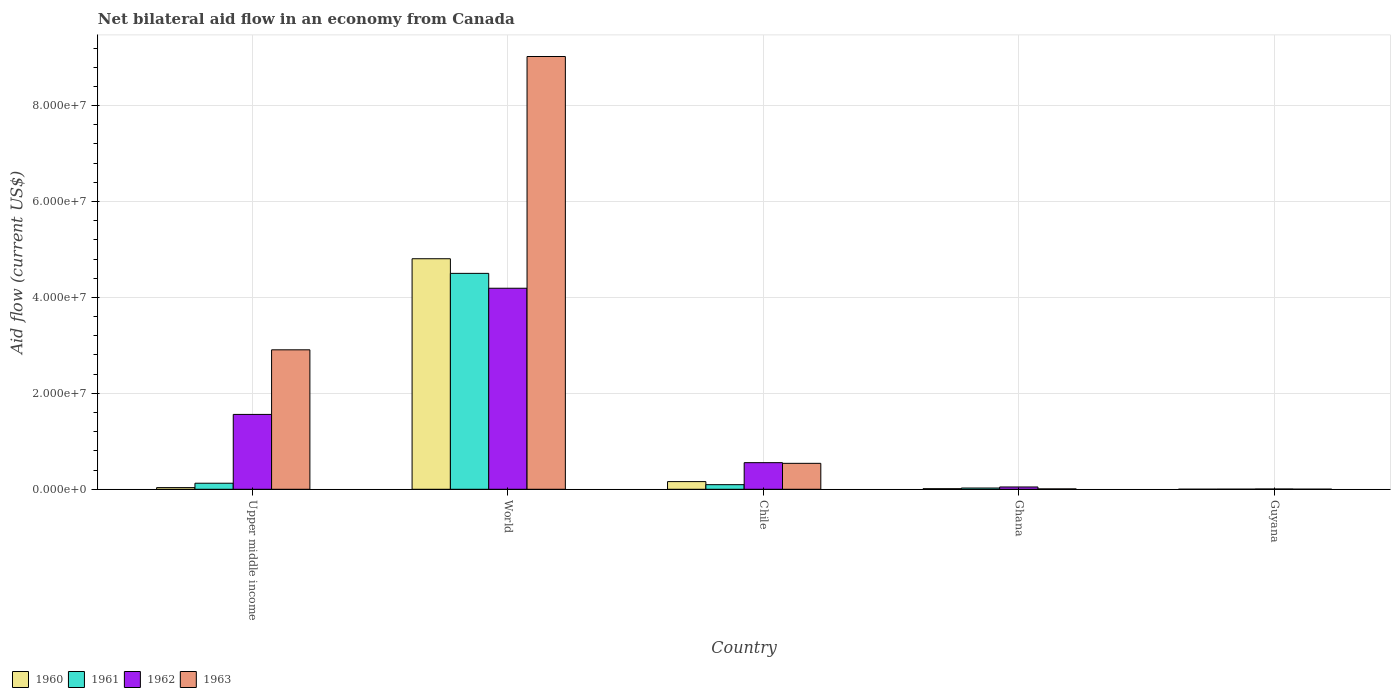How many different coloured bars are there?
Your response must be concise. 4. Are the number of bars per tick equal to the number of legend labels?
Your response must be concise. Yes. Are the number of bars on each tick of the X-axis equal?
Keep it short and to the point. Yes. How many bars are there on the 2nd tick from the left?
Provide a short and direct response. 4. What is the label of the 3rd group of bars from the left?
Provide a succinct answer. Chile. In how many cases, is the number of bars for a given country not equal to the number of legend labels?
Your answer should be very brief. 0. What is the net bilateral aid flow in 1961 in Ghana?
Provide a succinct answer. 2.60e+05. Across all countries, what is the maximum net bilateral aid flow in 1963?
Ensure brevity in your answer.  9.02e+07. In which country was the net bilateral aid flow in 1962 maximum?
Offer a terse response. World. In which country was the net bilateral aid flow in 1962 minimum?
Your answer should be very brief. Guyana. What is the total net bilateral aid flow in 1961 in the graph?
Your answer should be very brief. 4.75e+07. What is the difference between the net bilateral aid flow in 1962 in Ghana and that in Upper middle income?
Your answer should be compact. -1.51e+07. What is the difference between the net bilateral aid flow in 1961 in World and the net bilateral aid flow in 1962 in Chile?
Offer a very short reply. 3.95e+07. What is the average net bilateral aid flow in 1961 per country?
Keep it short and to the point. 9.50e+06. In how many countries, is the net bilateral aid flow in 1961 greater than 80000000 US$?
Make the answer very short. 0. What is the ratio of the net bilateral aid flow in 1960 in Ghana to that in Upper middle income?
Make the answer very short. 0.34. Is the difference between the net bilateral aid flow in 1962 in Guyana and World greater than the difference between the net bilateral aid flow in 1961 in Guyana and World?
Offer a terse response. Yes. What is the difference between the highest and the second highest net bilateral aid flow in 1962?
Give a very brief answer. 2.63e+07. What is the difference between the highest and the lowest net bilateral aid flow in 1962?
Provide a succinct answer. 4.19e+07. Is the sum of the net bilateral aid flow in 1963 in Chile and Upper middle income greater than the maximum net bilateral aid flow in 1962 across all countries?
Your answer should be compact. No. Are all the bars in the graph horizontal?
Provide a succinct answer. No. Does the graph contain any zero values?
Give a very brief answer. No. Does the graph contain grids?
Ensure brevity in your answer.  Yes. Where does the legend appear in the graph?
Give a very brief answer. Bottom left. How many legend labels are there?
Offer a very short reply. 4. How are the legend labels stacked?
Make the answer very short. Horizontal. What is the title of the graph?
Make the answer very short. Net bilateral aid flow in an economy from Canada. What is the label or title of the Y-axis?
Give a very brief answer. Aid flow (current US$). What is the Aid flow (current US$) in 1961 in Upper middle income?
Offer a very short reply. 1.26e+06. What is the Aid flow (current US$) in 1962 in Upper middle income?
Your answer should be very brief. 1.56e+07. What is the Aid flow (current US$) of 1963 in Upper middle income?
Ensure brevity in your answer.  2.91e+07. What is the Aid flow (current US$) in 1960 in World?
Make the answer very short. 4.81e+07. What is the Aid flow (current US$) of 1961 in World?
Ensure brevity in your answer.  4.50e+07. What is the Aid flow (current US$) in 1962 in World?
Ensure brevity in your answer.  4.19e+07. What is the Aid flow (current US$) in 1963 in World?
Your answer should be compact. 9.02e+07. What is the Aid flow (current US$) in 1960 in Chile?
Keep it short and to the point. 1.60e+06. What is the Aid flow (current US$) in 1961 in Chile?
Offer a very short reply. 9.60e+05. What is the Aid flow (current US$) of 1962 in Chile?
Provide a succinct answer. 5.55e+06. What is the Aid flow (current US$) in 1963 in Chile?
Your answer should be compact. 5.41e+06. What is the Aid flow (current US$) in 1960 in Ghana?
Your response must be concise. 1.20e+05. What is the Aid flow (current US$) of 1961 in Ghana?
Offer a terse response. 2.60e+05. What is the Aid flow (current US$) of 1962 in Ghana?
Keep it short and to the point. 4.80e+05. Across all countries, what is the maximum Aid flow (current US$) of 1960?
Your response must be concise. 4.81e+07. Across all countries, what is the maximum Aid flow (current US$) of 1961?
Make the answer very short. 4.50e+07. Across all countries, what is the maximum Aid flow (current US$) in 1962?
Give a very brief answer. 4.19e+07. Across all countries, what is the maximum Aid flow (current US$) of 1963?
Provide a short and direct response. 9.02e+07. Across all countries, what is the minimum Aid flow (current US$) of 1960?
Offer a terse response. 10000. Across all countries, what is the minimum Aid flow (current US$) in 1961?
Your response must be concise. 2.00e+04. Across all countries, what is the minimum Aid flow (current US$) in 1963?
Keep it short and to the point. 2.00e+04. What is the total Aid flow (current US$) of 1960 in the graph?
Keep it short and to the point. 5.02e+07. What is the total Aid flow (current US$) of 1961 in the graph?
Your answer should be compact. 4.75e+07. What is the total Aid flow (current US$) of 1962 in the graph?
Keep it short and to the point. 6.36e+07. What is the total Aid flow (current US$) in 1963 in the graph?
Give a very brief answer. 1.25e+08. What is the difference between the Aid flow (current US$) in 1960 in Upper middle income and that in World?
Give a very brief answer. -4.77e+07. What is the difference between the Aid flow (current US$) in 1961 in Upper middle income and that in World?
Make the answer very short. -4.38e+07. What is the difference between the Aid flow (current US$) in 1962 in Upper middle income and that in World?
Give a very brief answer. -2.63e+07. What is the difference between the Aid flow (current US$) in 1963 in Upper middle income and that in World?
Make the answer very short. -6.12e+07. What is the difference between the Aid flow (current US$) of 1960 in Upper middle income and that in Chile?
Your answer should be compact. -1.25e+06. What is the difference between the Aid flow (current US$) in 1962 in Upper middle income and that in Chile?
Ensure brevity in your answer.  1.01e+07. What is the difference between the Aid flow (current US$) in 1963 in Upper middle income and that in Chile?
Your answer should be very brief. 2.37e+07. What is the difference between the Aid flow (current US$) in 1960 in Upper middle income and that in Ghana?
Offer a terse response. 2.30e+05. What is the difference between the Aid flow (current US$) in 1962 in Upper middle income and that in Ghana?
Your response must be concise. 1.51e+07. What is the difference between the Aid flow (current US$) in 1963 in Upper middle income and that in Ghana?
Give a very brief answer. 2.90e+07. What is the difference between the Aid flow (current US$) in 1961 in Upper middle income and that in Guyana?
Keep it short and to the point. 1.24e+06. What is the difference between the Aid flow (current US$) of 1962 in Upper middle income and that in Guyana?
Keep it short and to the point. 1.56e+07. What is the difference between the Aid flow (current US$) in 1963 in Upper middle income and that in Guyana?
Offer a terse response. 2.91e+07. What is the difference between the Aid flow (current US$) in 1960 in World and that in Chile?
Your answer should be compact. 4.65e+07. What is the difference between the Aid flow (current US$) of 1961 in World and that in Chile?
Give a very brief answer. 4.41e+07. What is the difference between the Aid flow (current US$) of 1962 in World and that in Chile?
Offer a terse response. 3.64e+07. What is the difference between the Aid flow (current US$) in 1963 in World and that in Chile?
Your response must be concise. 8.48e+07. What is the difference between the Aid flow (current US$) in 1960 in World and that in Ghana?
Your answer should be compact. 4.80e+07. What is the difference between the Aid flow (current US$) in 1961 in World and that in Ghana?
Your answer should be very brief. 4.48e+07. What is the difference between the Aid flow (current US$) of 1962 in World and that in Ghana?
Ensure brevity in your answer.  4.14e+07. What is the difference between the Aid flow (current US$) of 1963 in World and that in Ghana?
Provide a short and direct response. 9.02e+07. What is the difference between the Aid flow (current US$) in 1960 in World and that in Guyana?
Offer a terse response. 4.81e+07. What is the difference between the Aid flow (current US$) of 1961 in World and that in Guyana?
Your answer should be very brief. 4.50e+07. What is the difference between the Aid flow (current US$) of 1962 in World and that in Guyana?
Your response must be concise. 4.19e+07. What is the difference between the Aid flow (current US$) in 1963 in World and that in Guyana?
Your answer should be very brief. 9.02e+07. What is the difference between the Aid flow (current US$) of 1960 in Chile and that in Ghana?
Your response must be concise. 1.48e+06. What is the difference between the Aid flow (current US$) of 1961 in Chile and that in Ghana?
Give a very brief answer. 7.00e+05. What is the difference between the Aid flow (current US$) in 1962 in Chile and that in Ghana?
Your answer should be very brief. 5.07e+06. What is the difference between the Aid flow (current US$) of 1963 in Chile and that in Ghana?
Offer a very short reply. 5.33e+06. What is the difference between the Aid flow (current US$) in 1960 in Chile and that in Guyana?
Your response must be concise. 1.59e+06. What is the difference between the Aid flow (current US$) of 1961 in Chile and that in Guyana?
Keep it short and to the point. 9.40e+05. What is the difference between the Aid flow (current US$) in 1962 in Chile and that in Guyana?
Offer a terse response. 5.49e+06. What is the difference between the Aid flow (current US$) of 1963 in Chile and that in Guyana?
Your answer should be very brief. 5.39e+06. What is the difference between the Aid flow (current US$) of 1960 in Ghana and that in Guyana?
Your response must be concise. 1.10e+05. What is the difference between the Aid flow (current US$) of 1961 in Ghana and that in Guyana?
Provide a short and direct response. 2.40e+05. What is the difference between the Aid flow (current US$) in 1962 in Ghana and that in Guyana?
Give a very brief answer. 4.20e+05. What is the difference between the Aid flow (current US$) of 1963 in Ghana and that in Guyana?
Give a very brief answer. 6.00e+04. What is the difference between the Aid flow (current US$) of 1960 in Upper middle income and the Aid flow (current US$) of 1961 in World?
Keep it short and to the point. -4.47e+07. What is the difference between the Aid flow (current US$) of 1960 in Upper middle income and the Aid flow (current US$) of 1962 in World?
Give a very brief answer. -4.16e+07. What is the difference between the Aid flow (current US$) in 1960 in Upper middle income and the Aid flow (current US$) in 1963 in World?
Ensure brevity in your answer.  -8.99e+07. What is the difference between the Aid flow (current US$) of 1961 in Upper middle income and the Aid flow (current US$) of 1962 in World?
Give a very brief answer. -4.07e+07. What is the difference between the Aid flow (current US$) in 1961 in Upper middle income and the Aid flow (current US$) in 1963 in World?
Offer a terse response. -8.90e+07. What is the difference between the Aid flow (current US$) of 1962 in Upper middle income and the Aid flow (current US$) of 1963 in World?
Give a very brief answer. -7.46e+07. What is the difference between the Aid flow (current US$) of 1960 in Upper middle income and the Aid flow (current US$) of 1961 in Chile?
Your answer should be very brief. -6.10e+05. What is the difference between the Aid flow (current US$) of 1960 in Upper middle income and the Aid flow (current US$) of 1962 in Chile?
Give a very brief answer. -5.20e+06. What is the difference between the Aid flow (current US$) in 1960 in Upper middle income and the Aid flow (current US$) in 1963 in Chile?
Provide a succinct answer. -5.06e+06. What is the difference between the Aid flow (current US$) of 1961 in Upper middle income and the Aid flow (current US$) of 1962 in Chile?
Your answer should be compact. -4.29e+06. What is the difference between the Aid flow (current US$) in 1961 in Upper middle income and the Aid flow (current US$) in 1963 in Chile?
Offer a terse response. -4.15e+06. What is the difference between the Aid flow (current US$) in 1962 in Upper middle income and the Aid flow (current US$) in 1963 in Chile?
Keep it short and to the point. 1.02e+07. What is the difference between the Aid flow (current US$) of 1960 in Upper middle income and the Aid flow (current US$) of 1961 in Ghana?
Offer a very short reply. 9.00e+04. What is the difference between the Aid flow (current US$) in 1960 in Upper middle income and the Aid flow (current US$) in 1962 in Ghana?
Provide a short and direct response. -1.30e+05. What is the difference between the Aid flow (current US$) of 1961 in Upper middle income and the Aid flow (current US$) of 1962 in Ghana?
Provide a succinct answer. 7.80e+05. What is the difference between the Aid flow (current US$) of 1961 in Upper middle income and the Aid flow (current US$) of 1963 in Ghana?
Ensure brevity in your answer.  1.18e+06. What is the difference between the Aid flow (current US$) of 1962 in Upper middle income and the Aid flow (current US$) of 1963 in Ghana?
Offer a very short reply. 1.55e+07. What is the difference between the Aid flow (current US$) of 1960 in Upper middle income and the Aid flow (current US$) of 1962 in Guyana?
Give a very brief answer. 2.90e+05. What is the difference between the Aid flow (current US$) in 1961 in Upper middle income and the Aid flow (current US$) in 1962 in Guyana?
Your answer should be compact. 1.20e+06. What is the difference between the Aid flow (current US$) of 1961 in Upper middle income and the Aid flow (current US$) of 1963 in Guyana?
Ensure brevity in your answer.  1.24e+06. What is the difference between the Aid flow (current US$) in 1962 in Upper middle income and the Aid flow (current US$) in 1963 in Guyana?
Make the answer very short. 1.56e+07. What is the difference between the Aid flow (current US$) in 1960 in World and the Aid flow (current US$) in 1961 in Chile?
Your answer should be compact. 4.71e+07. What is the difference between the Aid flow (current US$) of 1960 in World and the Aid flow (current US$) of 1962 in Chile?
Provide a short and direct response. 4.25e+07. What is the difference between the Aid flow (current US$) of 1960 in World and the Aid flow (current US$) of 1963 in Chile?
Give a very brief answer. 4.27e+07. What is the difference between the Aid flow (current US$) of 1961 in World and the Aid flow (current US$) of 1962 in Chile?
Keep it short and to the point. 3.95e+07. What is the difference between the Aid flow (current US$) of 1961 in World and the Aid flow (current US$) of 1963 in Chile?
Your answer should be very brief. 3.96e+07. What is the difference between the Aid flow (current US$) of 1962 in World and the Aid flow (current US$) of 1963 in Chile?
Offer a terse response. 3.65e+07. What is the difference between the Aid flow (current US$) of 1960 in World and the Aid flow (current US$) of 1961 in Ghana?
Keep it short and to the point. 4.78e+07. What is the difference between the Aid flow (current US$) of 1960 in World and the Aid flow (current US$) of 1962 in Ghana?
Offer a very short reply. 4.76e+07. What is the difference between the Aid flow (current US$) in 1960 in World and the Aid flow (current US$) in 1963 in Ghana?
Your answer should be very brief. 4.80e+07. What is the difference between the Aid flow (current US$) of 1961 in World and the Aid flow (current US$) of 1962 in Ghana?
Provide a succinct answer. 4.45e+07. What is the difference between the Aid flow (current US$) of 1961 in World and the Aid flow (current US$) of 1963 in Ghana?
Make the answer very short. 4.49e+07. What is the difference between the Aid flow (current US$) of 1962 in World and the Aid flow (current US$) of 1963 in Ghana?
Provide a short and direct response. 4.18e+07. What is the difference between the Aid flow (current US$) of 1960 in World and the Aid flow (current US$) of 1961 in Guyana?
Offer a very short reply. 4.80e+07. What is the difference between the Aid flow (current US$) of 1960 in World and the Aid flow (current US$) of 1962 in Guyana?
Offer a very short reply. 4.80e+07. What is the difference between the Aid flow (current US$) of 1960 in World and the Aid flow (current US$) of 1963 in Guyana?
Ensure brevity in your answer.  4.80e+07. What is the difference between the Aid flow (current US$) of 1961 in World and the Aid flow (current US$) of 1962 in Guyana?
Ensure brevity in your answer.  4.50e+07. What is the difference between the Aid flow (current US$) of 1961 in World and the Aid flow (current US$) of 1963 in Guyana?
Provide a short and direct response. 4.50e+07. What is the difference between the Aid flow (current US$) in 1962 in World and the Aid flow (current US$) in 1963 in Guyana?
Provide a succinct answer. 4.19e+07. What is the difference between the Aid flow (current US$) in 1960 in Chile and the Aid flow (current US$) in 1961 in Ghana?
Provide a succinct answer. 1.34e+06. What is the difference between the Aid flow (current US$) in 1960 in Chile and the Aid flow (current US$) in 1962 in Ghana?
Ensure brevity in your answer.  1.12e+06. What is the difference between the Aid flow (current US$) of 1960 in Chile and the Aid flow (current US$) of 1963 in Ghana?
Your answer should be very brief. 1.52e+06. What is the difference between the Aid flow (current US$) of 1961 in Chile and the Aid flow (current US$) of 1963 in Ghana?
Your answer should be very brief. 8.80e+05. What is the difference between the Aid flow (current US$) of 1962 in Chile and the Aid flow (current US$) of 1963 in Ghana?
Provide a succinct answer. 5.47e+06. What is the difference between the Aid flow (current US$) of 1960 in Chile and the Aid flow (current US$) of 1961 in Guyana?
Your answer should be very brief. 1.58e+06. What is the difference between the Aid flow (current US$) of 1960 in Chile and the Aid flow (current US$) of 1962 in Guyana?
Provide a short and direct response. 1.54e+06. What is the difference between the Aid flow (current US$) of 1960 in Chile and the Aid flow (current US$) of 1963 in Guyana?
Provide a succinct answer. 1.58e+06. What is the difference between the Aid flow (current US$) in 1961 in Chile and the Aid flow (current US$) in 1962 in Guyana?
Offer a terse response. 9.00e+05. What is the difference between the Aid flow (current US$) of 1961 in Chile and the Aid flow (current US$) of 1963 in Guyana?
Offer a terse response. 9.40e+05. What is the difference between the Aid flow (current US$) in 1962 in Chile and the Aid flow (current US$) in 1963 in Guyana?
Your response must be concise. 5.53e+06. What is the difference between the Aid flow (current US$) in 1960 in Ghana and the Aid flow (current US$) in 1962 in Guyana?
Your answer should be compact. 6.00e+04. What is the difference between the Aid flow (current US$) of 1961 in Ghana and the Aid flow (current US$) of 1963 in Guyana?
Provide a succinct answer. 2.40e+05. What is the difference between the Aid flow (current US$) of 1962 in Ghana and the Aid flow (current US$) of 1963 in Guyana?
Your response must be concise. 4.60e+05. What is the average Aid flow (current US$) of 1960 per country?
Your answer should be compact. 1.00e+07. What is the average Aid flow (current US$) in 1961 per country?
Provide a short and direct response. 9.50e+06. What is the average Aid flow (current US$) in 1962 per country?
Your answer should be compact. 1.27e+07. What is the average Aid flow (current US$) in 1963 per country?
Ensure brevity in your answer.  2.50e+07. What is the difference between the Aid flow (current US$) in 1960 and Aid flow (current US$) in 1961 in Upper middle income?
Make the answer very short. -9.10e+05. What is the difference between the Aid flow (current US$) in 1960 and Aid flow (current US$) in 1962 in Upper middle income?
Offer a very short reply. -1.53e+07. What is the difference between the Aid flow (current US$) in 1960 and Aid flow (current US$) in 1963 in Upper middle income?
Give a very brief answer. -2.87e+07. What is the difference between the Aid flow (current US$) of 1961 and Aid flow (current US$) of 1962 in Upper middle income?
Your answer should be very brief. -1.44e+07. What is the difference between the Aid flow (current US$) of 1961 and Aid flow (current US$) of 1963 in Upper middle income?
Offer a very short reply. -2.78e+07. What is the difference between the Aid flow (current US$) of 1962 and Aid flow (current US$) of 1963 in Upper middle income?
Offer a very short reply. -1.35e+07. What is the difference between the Aid flow (current US$) of 1960 and Aid flow (current US$) of 1961 in World?
Your response must be concise. 3.05e+06. What is the difference between the Aid flow (current US$) of 1960 and Aid flow (current US$) of 1962 in World?
Make the answer very short. 6.15e+06. What is the difference between the Aid flow (current US$) in 1960 and Aid flow (current US$) in 1963 in World?
Ensure brevity in your answer.  -4.22e+07. What is the difference between the Aid flow (current US$) in 1961 and Aid flow (current US$) in 1962 in World?
Your answer should be compact. 3.10e+06. What is the difference between the Aid flow (current US$) in 1961 and Aid flow (current US$) in 1963 in World?
Your response must be concise. -4.52e+07. What is the difference between the Aid flow (current US$) of 1962 and Aid flow (current US$) of 1963 in World?
Offer a very short reply. -4.83e+07. What is the difference between the Aid flow (current US$) in 1960 and Aid flow (current US$) in 1961 in Chile?
Offer a very short reply. 6.40e+05. What is the difference between the Aid flow (current US$) of 1960 and Aid flow (current US$) of 1962 in Chile?
Make the answer very short. -3.95e+06. What is the difference between the Aid flow (current US$) of 1960 and Aid flow (current US$) of 1963 in Chile?
Your answer should be compact. -3.81e+06. What is the difference between the Aid flow (current US$) in 1961 and Aid flow (current US$) in 1962 in Chile?
Your answer should be very brief. -4.59e+06. What is the difference between the Aid flow (current US$) in 1961 and Aid flow (current US$) in 1963 in Chile?
Provide a succinct answer. -4.45e+06. What is the difference between the Aid flow (current US$) of 1962 and Aid flow (current US$) of 1963 in Chile?
Your answer should be compact. 1.40e+05. What is the difference between the Aid flow (current US$) of 1960 and Aid flow (current US$) of 1962 in Ghana?
Keep it short and to the point. -3.60e+05. What is the difference between the Aid flow (current US$) of 1961 and Aid flow (current US$) of 1962 in Ghana?
Provide a succinct answer. -2.20e+05. What is the difference between the Aid flow (current US$) of 1962 and Aid flow (current US$) of 1963 in Ghana?
Make the answer very short. 4.00e+05. What is the difference between the Aid flow (current US$) in 1960 and Aid flow (current US$) in 1962 in Guyana?
Offer a very short reply. -5.00e+04. What is the difference between the Aid flow (current US$) of 1961 and Aid flow (current US$) of 1962 in Guyana?
Your response must be concise. -4.00e+04. What is the difference between the Aid flow (current US$) of 1962 and Aid flow (current US$) of 1963 in Guyana?
Your answer should be very brief. 4.00e+04. What is the ratio of the Aid flow (current US$) of 1960 in Upper middle income to that in World?
Provide a succinct answer. 0.01. What is the ratio of the Aid flow (current US$) in 1961 in Upper middle income to that in World?
Make the answer very short. 0.03. What is the ratio of the Aid flow (current US$) in 1962 in Upper middle income to that in World?
Make the answer very short. 0.37. What is the ratio of the Aid flow (current US$) of 1963 in Upper middle income to that in World?
Offer a terse response. 0.32. What is the ratio of the Aid flow (current US$) in 1960 in Upper middle income to that in Chile?
Give a very brief answer. 0.22. What is the ratio of the Aid flow (current US$) of 1961 in Upper middle income to that in Chile?
Your answer should be very brief. 1.31. What is the ratio of the Aid flow (current US$) in 1962 in Upper middle income to that in Chile?
Ensure brevity in your answer.  2.81. What is the ratio of the Aid flow (current US$) in 1963 in Upper middle income to that in Chile?
Keep it short and to the point. 5.38. What is the ratio of the Aid flow (current US$) of 1960 in Upper middle income to that in Ghana?
Provide a succinct answer. 2.92. What is the ratio of the Aid flow (current US$) of 1961 in Upper middle income to that in Ghana?
Keep it short and to the point. 4.85. What is the ratio of the Aid flow (current US$) of 1962 in Upper middle income to that in Ghana?
Your answer should be very brief. 32.52. What is the ratio of the Aid flow (current US$) in 1963 in Upper middle income to that in Ghana?
Your answer should be very brief. 363.5. What is the ratio of the Aid flow (current US$) in 1962 in Upper middle income to that in Guyana?
Your response must be concise. 260.17. What is the ratio of the Aid flow (current US$) in 1963 in Upper middle income to that in Guyana?
Provide a succinct answer. 1454. What is the ratio of the Aid flow (current US$) of 1960 in World to that in Chile?
Your response must be concise. 30.04. What is the ratio of the Aid flow (current US$) of 1961 in World to that in Chile?
Offer a terse response. 46.9. What is the ratio of the Aid flow (current US$) in 1962 in World to that in Chile?
Keep it short and to the point. 7.55. What is the ratio of the Aid flow (current US$) of 1963 in World to that in Chile?
Make the answer very short. 16.68. What is the ratio of the Aid flow (current US$) of 1960 in World to that in Ghana?
Make the answer very short. 400.58. What is the ratio of the Aid flow (current US$) of 1961 in World to that in Ghana?
Offer a terse response. 173.15. What is the ratio of the Aid flow (current US$) of 1962 in World to that in Ghana?
Give a very brief answer. 87.33. What is the ratio of the Aid flow (current US$) in 1963 in World to that in Ghana?
Give a very brief answer. 1128. What is the ratio of the Aid flow (current US$) in 1960 in World to that in Guyana?
Keep it short and to the point. 4807. What is the ratio of the Aid flow (current US$) of 1961 in World to that in Guyana?
Offer a terse response. 2251. What is the ratio of the Aid flow (current US$) in 1962 in World to that in Guyana?
Ensure brevity in your answer.  698.67. What is the ratio of the Aid flow (current US$) in 1963 in World to that in Guyana?
Your answer should be very brief. 4512. What is the ratio of the Aid flow (current US$) of 1960 in Chile to that in Ghana?
Offer a terse response. 13.33. What is the ratio of the Aid flow (current US$) in 1961 in Chile to that in Ghana?
Offer a very short reply. 3.69. What is the ratio of the Aid flow (current US$) of 1962 in Chile to that in Ghana?
Your answer should be very brief. 11.56. What is the ratio of the Aid flow (current US$) in 1963 in Chile to that in Ghana?
Your response must be concise. 67.62. What is the ratio of the Aid flow (current US$) of 1960 in Chile to that in Guyana?
Your answer should be compact. 160. What is the ratio of the Aid flow (current US$) of 1961 in Chile to that in Guyana?
Provide a short and direct response. 48. What is the ratio of the Aid flow (current US$) of 1962 in Chile to that in Guyana?
Your answer should be compact. 92.5. What is the ratio of the Aid flow (current US$) of 1963 in Chile to that in Guyana?
Your answer should be compact. 270.5. What is the ratio of the Aid flow (current US$) in 1960 in Ghana to that in Guyana?
Keep it short and to the point. 12. What is the ratio of the Aid flow (current US$) in 1961 in Ghana to that in Guyana?
Keep it short and to the point. 13. What is the ratio of the Aid flow (current US$) in 1963 in Ghana to that in Guyana?
Offer a terse response. 4. What is the difference between the highest and the second highest Aid flow (current US$) of 1960?
Your response must be concise. 4.65e+07. What is the difference between the highest and the second highest Aid flow (current US$) of 1961?
Offer a terse response. 4.38e+07. What is the difference between the highest and the second highest Aid flow (current US$) of 1962?
Provide a short and direct response. 2.63e+07. What is the difference between the highest and the second highest Aid flow (current US$) in 1963?
Offer a terse response. 6.12e+07. What is the difference between the highest and the lowest Aid flow (current US$) in 1960?
Give a very brief answer. 4.81e+07. What is the difference between the highest and the lowest Aid flow (current US$) of 1961?
Your answer should be compact. 4.50e+07. What is the difference between the highest and the lowest Aid flow (current US$) of 1962?
Make the answer very short. 4.19e+07. What is the difference between the highest and the lowest Aid flow (current US$) of 1963?
Provide a succinct answer. 9.02e+07. 